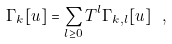<formula> <loc_0><loc_0><loc_500><loc_500>\Gamma _ { k } [ u ] = \sum _ { l \geq 0 } T ^ { l } \Gamma _ { k , l } [ u ] \ ,</formula> 